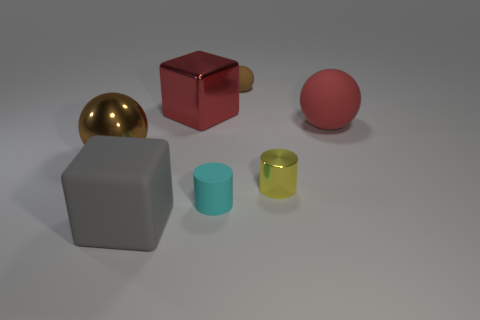Add 3 cyan rubber objects. How many objects exist? 10 Subtract all spheres. How many objects are left? 4 Add 7 brown matte spheres. How many brown matte spheres exist? 8 Subtract 0 yellow balls. How many objects are left? 7 Subtract all large gray blocks. Subtract all big gray things. How many objects are left? 5 Add 6 balls. How many balls are left? 9 